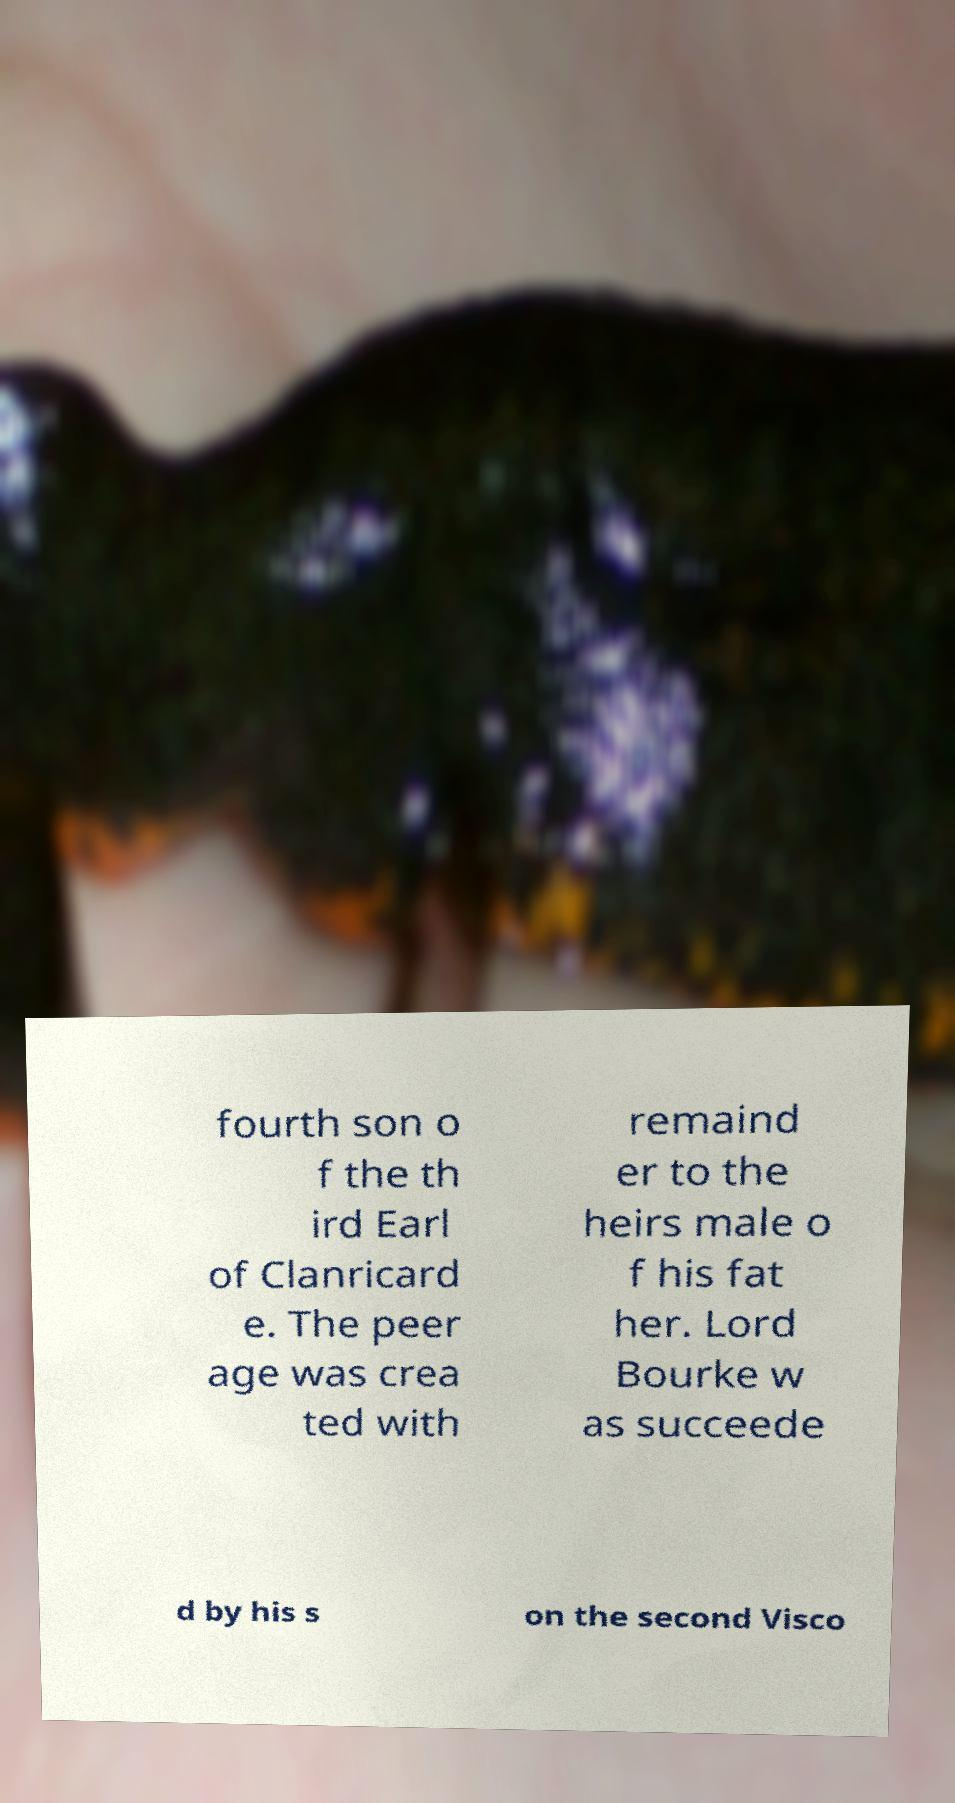Please read and relay the text visible in this image. What does it say? fourth son o f the th ird Earl of Clanricard e. The peer age was crea ted with remaind er to the heirs male o f his fat her. Lord Bourke w as succeede d by his s on the second Visco 